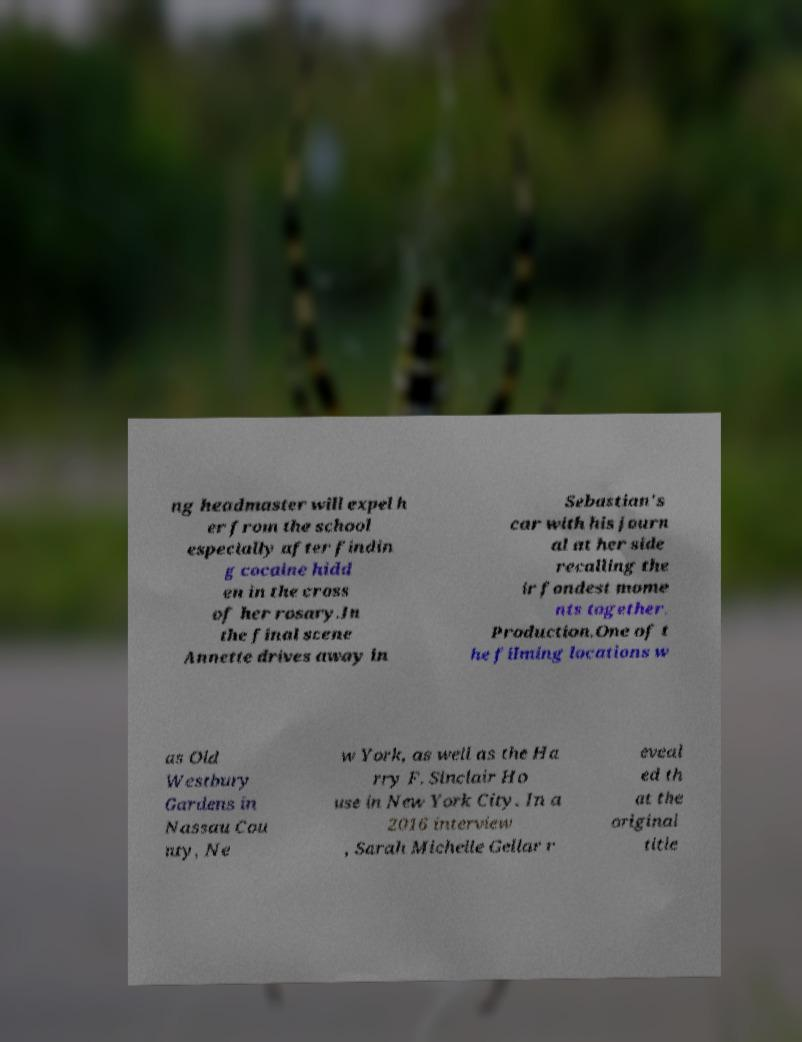Could you extract and type out the text from this image? ng headmaster will expel h er from the school especially after findin g cocaine hidd en in the cross of her rosary.In the final scene Annette drives away in Sebastian's car with his journ al at her side recalling the ir fondest mome nts together. Production.One of t he filming locations w as Old Westbury Gardens in Nassau Cou nty, Ne w York, as well as the Ha rry F. Sinclair Ho use in New York City. In a 2016 interview , Sarah Michelle Gellar r eveal ed th at the original title 